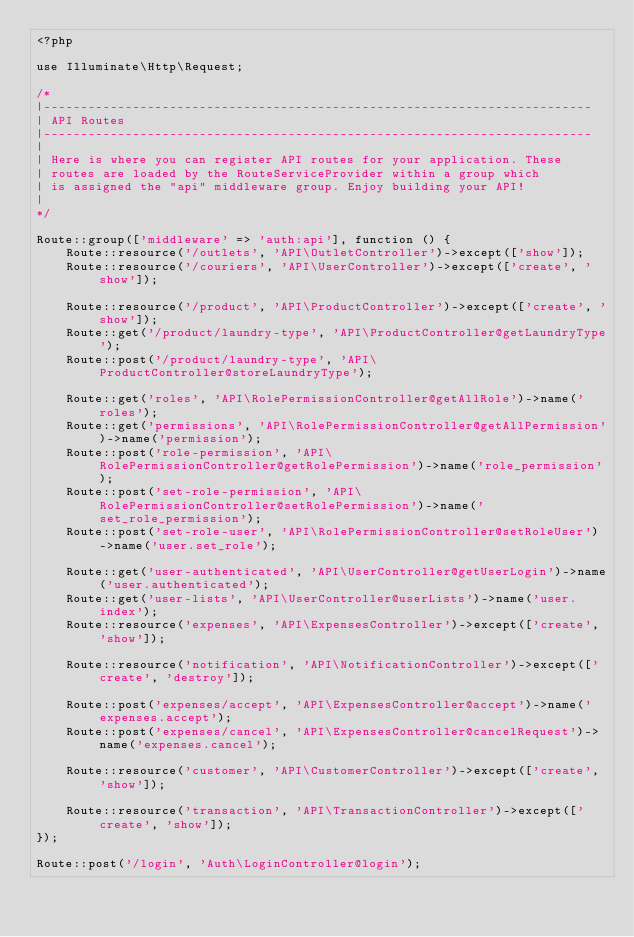Convert code to text. <code><loc_0><loc_0><loc_500><loc_500><_PHP_><?php

use Illuminate\Http\Request;

/*
|--------------------------------------------------------------------------
| API Routes
|--------------------------------------------------------------------------
|
| Here is where you can register API routes for your application. These
| routes are loaded by the RouteServiceProvider within a group which
| is assigned the "api" middleware group. Enjoy building your API!
|
*/

Route::group(['middleware' => 'auth:api'], function () {
    Route::resource('/outlets', 'API\OutletController')->except(['show']);
    Route::resource('/couriers', 'API\UserController')->except(['create', 'show']);

    Route::resource('/product', 'API\ProductController')->except(['create', 'show']);
    Route::get('/product/laundry-type', 'API\ProductController@getLaundryType');
    Route::post('/product/laundry-type', 'API\ProductController@storeLaundryType');

    Route::get('roles', 'API\RolePermissionController@getAllRole')->name('roles');
    Route::get('permissions', 'API\RolePermissionController@getAllPermission')->name('permission');
    Route::post('role-permission', 'API\RolePermissionController@getRolePermission')->name('role_permission');
    Route::post('set-role-permission', 'API\RolePermissionController@setRolePermission')->name('set_role_permission');
    Route::post('set-role-user', 'API\RolePermissionController@setRoleUser')->name('user.set_role');

    Route::get('user-authenticated', 'API\UserController@getUserLogin')->name('user.authenticated');
    Route::get('user-lists', 'API\UserController@userLists')->name('user.index');
    Route::resource('expenses', 'API\ExpensesController')->except(['create', 'show']);

    Route::resource('notification', 'API\NotificationController')->except(['create', 'destroy']);

    Route::post('expenses/accept', 'API\ExpensesController@accept')->name('expenses.accept');
    Route::post('expenses/cancel', 'API\ExpensesController@cancelRequest')->name('expenses.cancel');

    Route::resource('customer', 'API\CustomerController')->except(['create', 'show']);

    Route::resource('transaction', 'API\TransactionController')->except(['create', 'show']);
});

Route::post('/login', 'Auth\LoginController@login');
</code> 